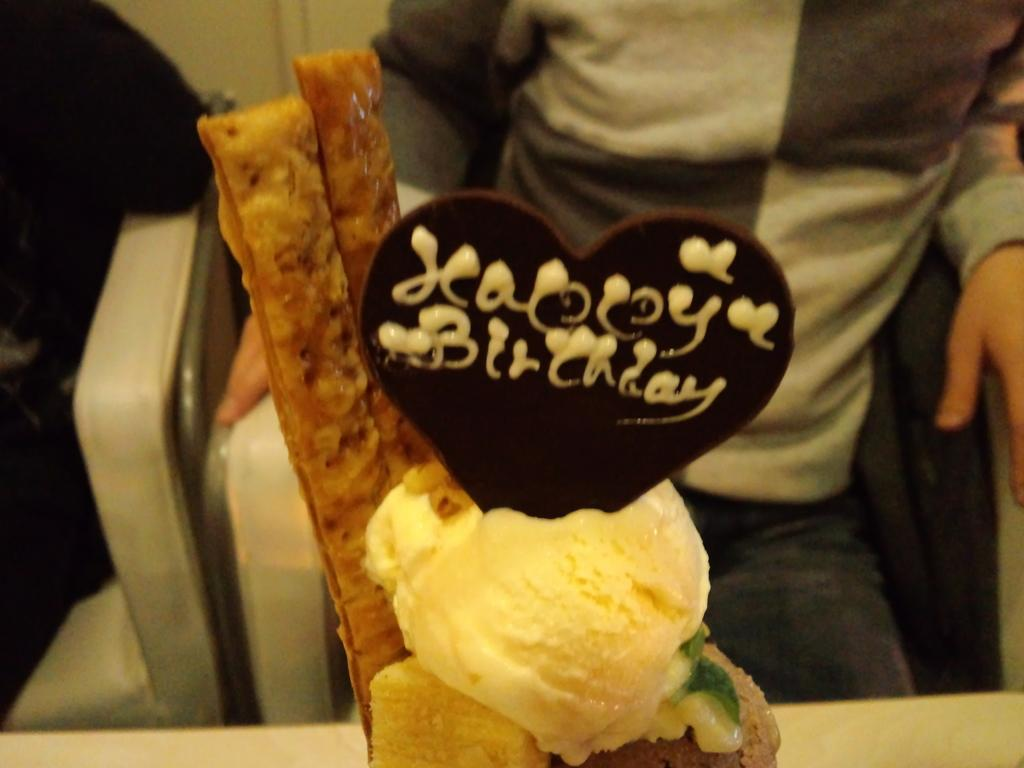What is the main subject of the image? The main subject of the image is ice cream. Can you describe the appearance of the ice cream? The ice cream has a cream and brown color. Is there anyone else in the image besides the ice cream? Yes, there is a person sitting in the background of the image. What is the person wearing? The person is wearing a gray and white shirt. What type of map is the person holding in the image? There is no map present in the image; the person is sitting and wearing a gray and white shirt. 